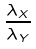<formula> <loc_0><loc_0><loc_500><loc_500>\frac { \lambda _ { X } } { \lambda _ { Y } }</formula> 